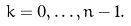<formula> <loc_0><loc_0><loc_500><loc_500>k = 0 , \dots , n - 1 .</formula> 